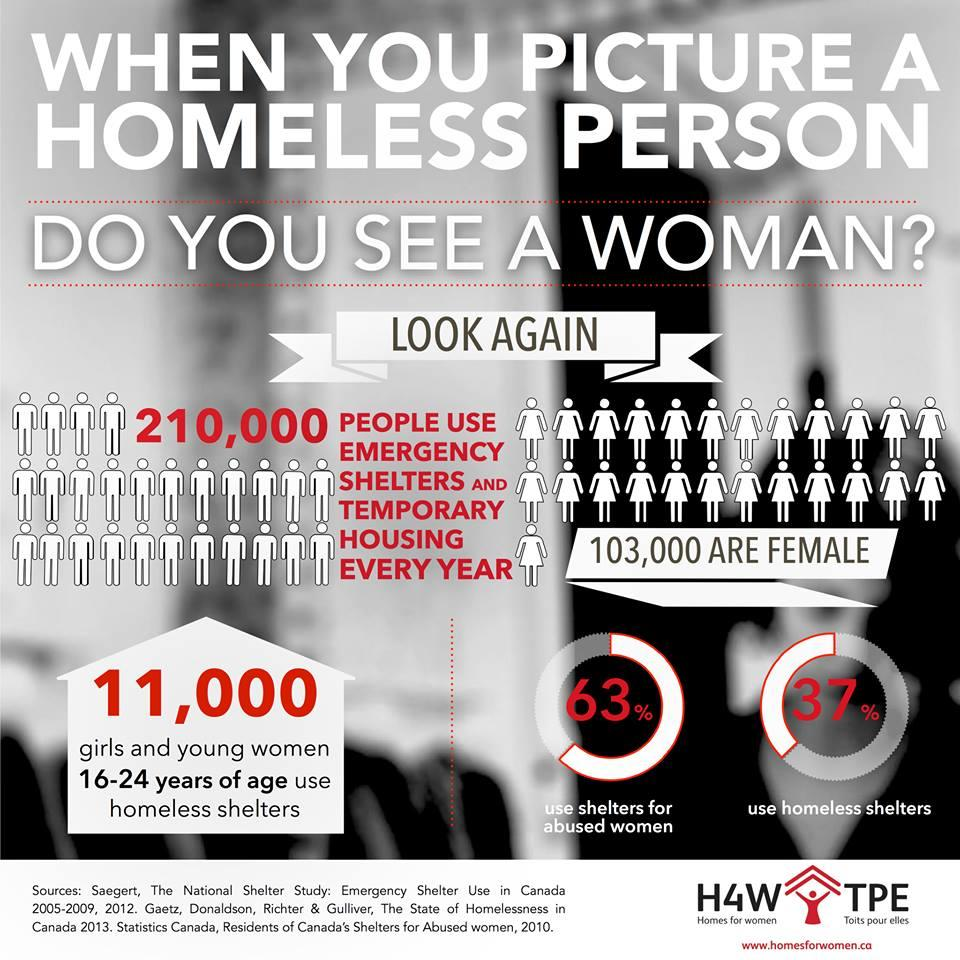Indicate a few pertinent items in this graphic. According to a recent survey, 37% of people in Canada use homeless shelters. In Canada, approximately 11,000 girls and young women aged 16-24 years use homeless shelters. 